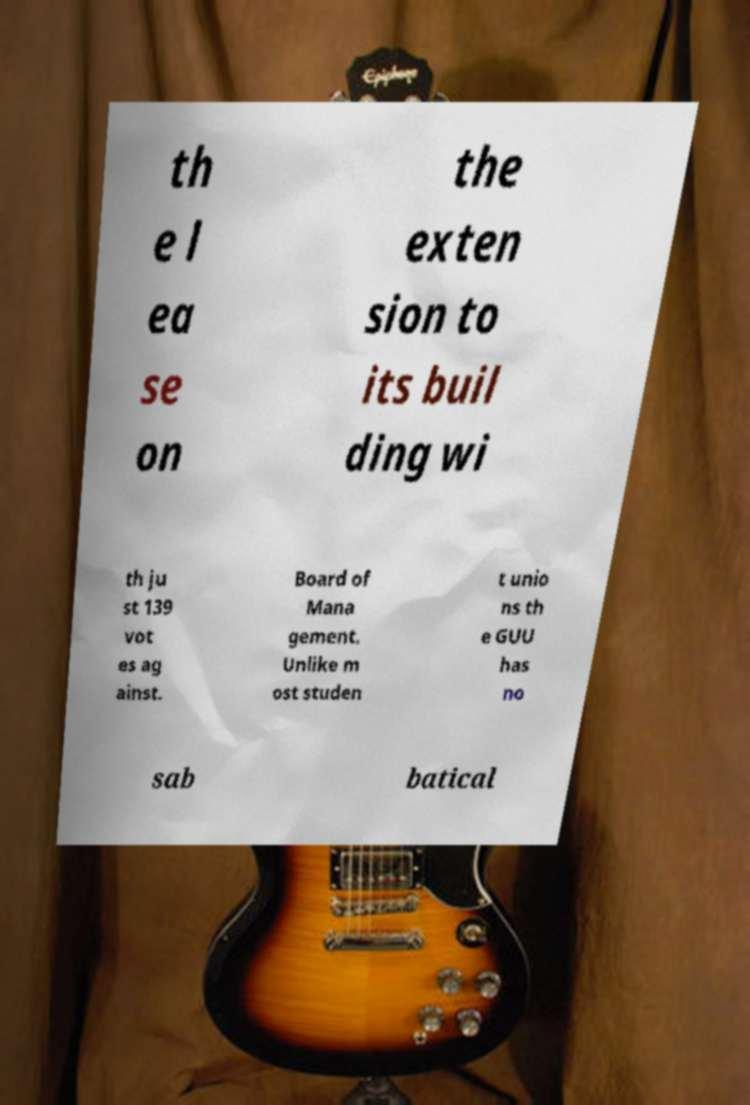Could you extract and type out the text from this image? th e l ea se on the exten sion to its buil ding wi th ju st 139 vot es ag ainst. Board of Mana gement. Unlike m ost studen t unio ns th e GUU has no sab batical 